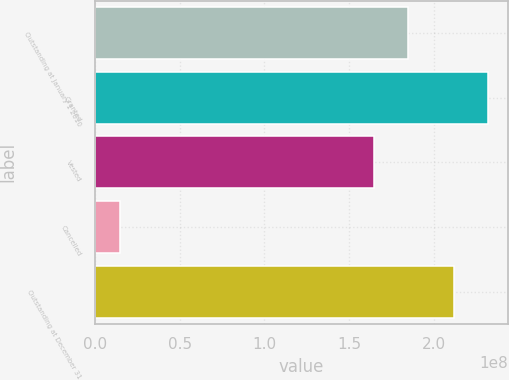Convert chart to OTSL. <chart><loc_0><loc_0><loc_500><loc_500><bar_chart><fcel>Outstanding at January 1 2010<fcel>Granted<fcel>Vested<fcel>Cancelled<fcel>Outstanding at December 31<nl><fcel>1.851e+08<fcel>2.32268e+08<fcel>1.64905e+08<fcel>1.49245e+07<fcel>2.12073e+08<nl></chart> 